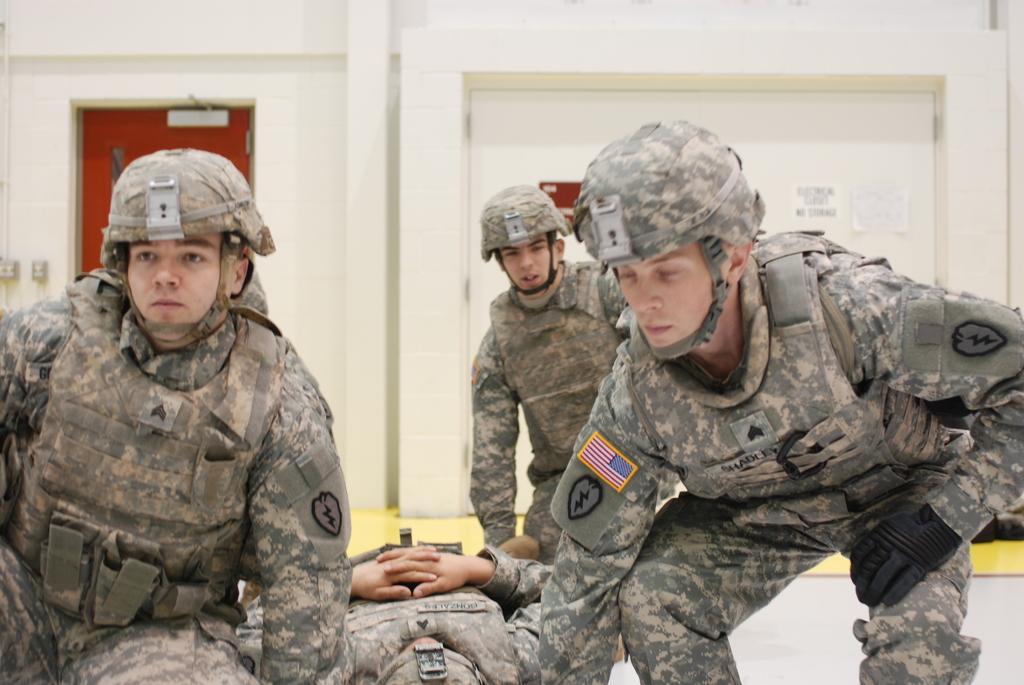How would you summarize this image in a sentence or two? In this image, we can see few people are in military uniform. Here a person is lying. Background we can see wall, door, posters and few objects. At the bottom of the image, we can see a floor. 